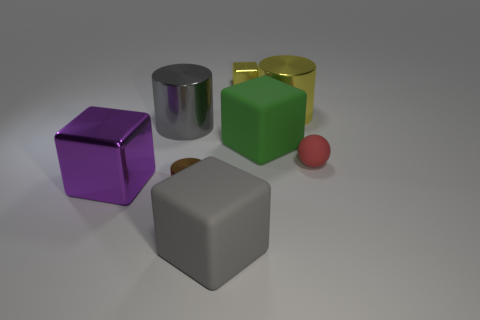Add 2 large purple metallic blocks. How many objects exist? 10 Subtract all large cylinders. How many cylinders are left? 1 Subtract all green blocks. How many blocks are left? 3 Subtract 2 blocks. How many blocks are left? 2 Subtract all balls. How many objects are left? 7 Add 6 yellow metallic cylinders. How many yellow metallic cylinders are left? 7 Add 5 tiny matte things. How many tiny matte things exist? 6 Subtract 0 cyan cylinders. How many objects are left? 8 Subtract all green blocks. Subtract all cyan spheres. How many blocks are left? 3 Subtract all small spheres. Subtract all big purple things. How many objects are left? 6 